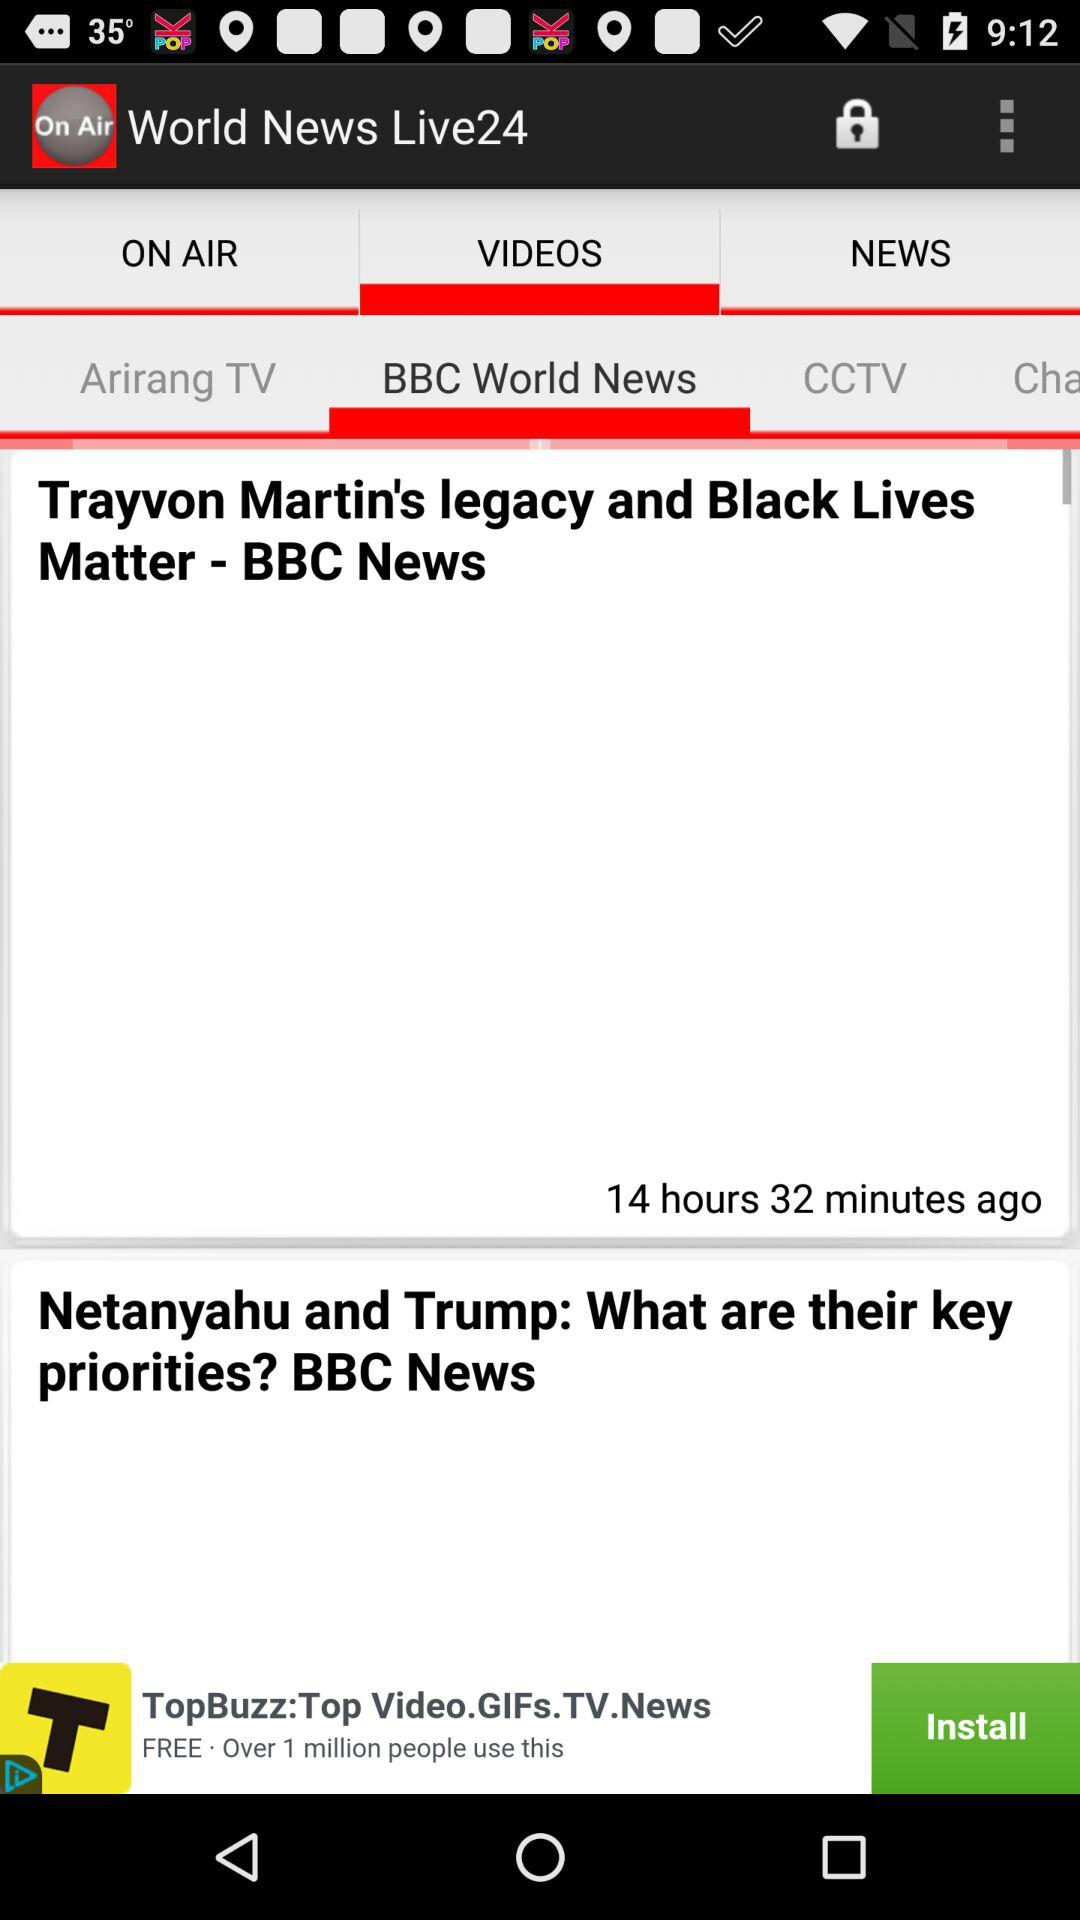What is the app name? The app name is "World News Live24". 